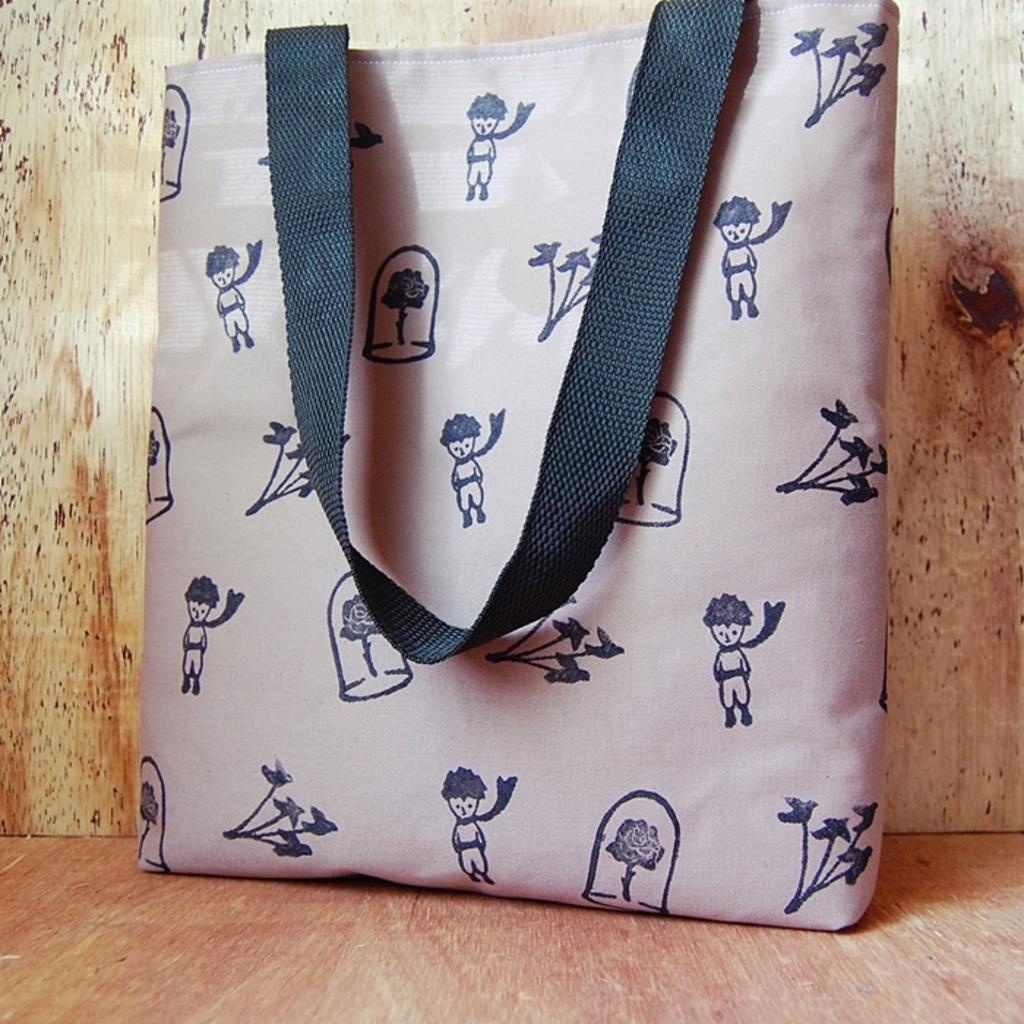What object is located on the floor in the image? There is a bag placed on the floor in the image. Can you describe the background of the image? There is a wall in the background of the image. What actor is reading a book in the image? There is no actor or book present in the image; it only features a bag placed on the floor and a wall in the background. 